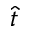<formula> <loc_0><loc_0><loc_500><loc_500>\hat { t }</formula> 